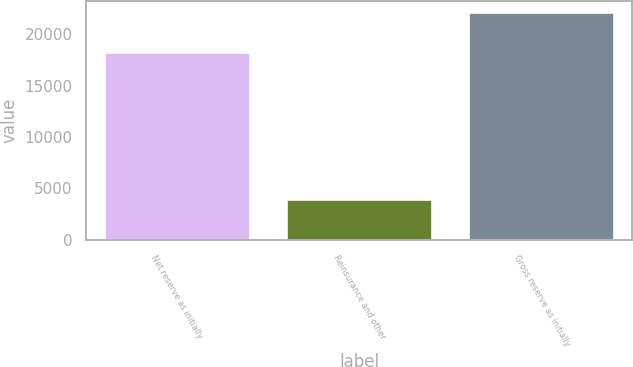Convert chart to OTSL. <chart><loc_0><loc_0><loc_500><loc_500><bar_chart><fcel>Net reserve as initially<fcel>Reinsurance and other<fcel>Gross reserve as initially<nl><fcel>18231<fcel>3922<fcel>22153<nl></chart> 